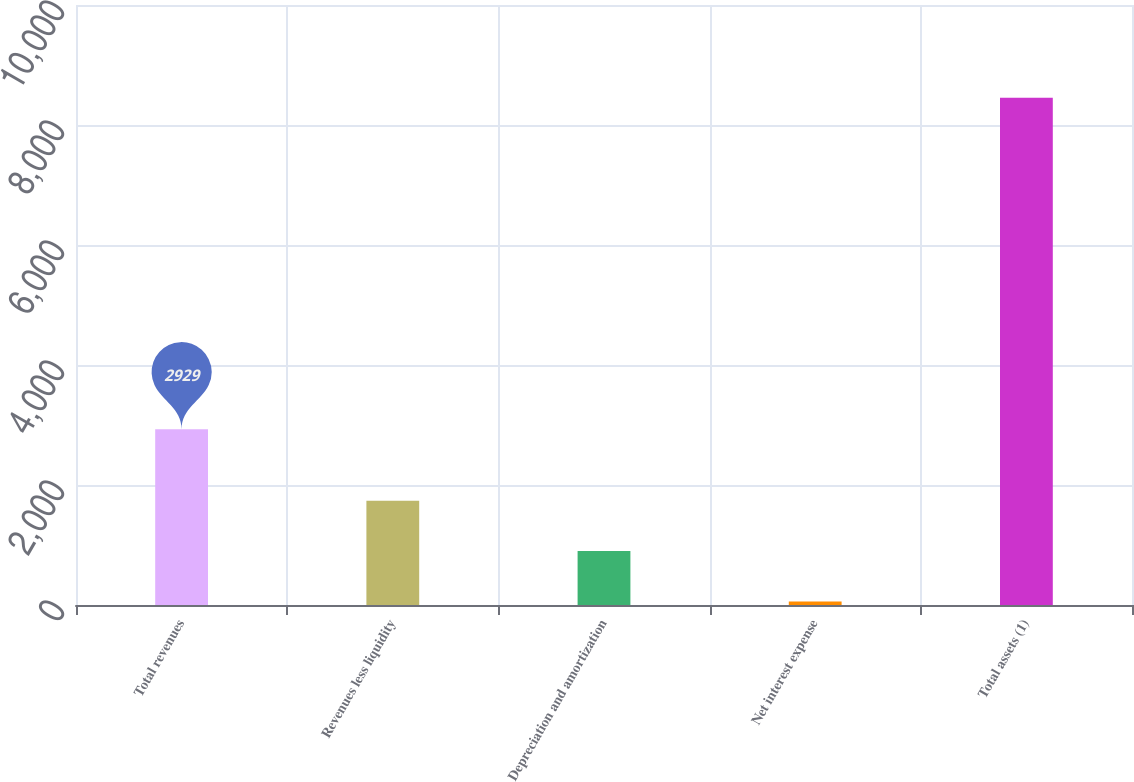Convert chart. <chart><loc_0><loc_0><loc_500><loc_500><bar_chart><fcel>Total revenues<fcel>Revenues less liquidity<fcel>Depreciation and amortization<fcel>Net interest expense<fcel>Total assets (1)<nl><fcel>2929<fcel>1737.8<fcel>898.4<fcel>59<fcel>8453<nl></chart> 